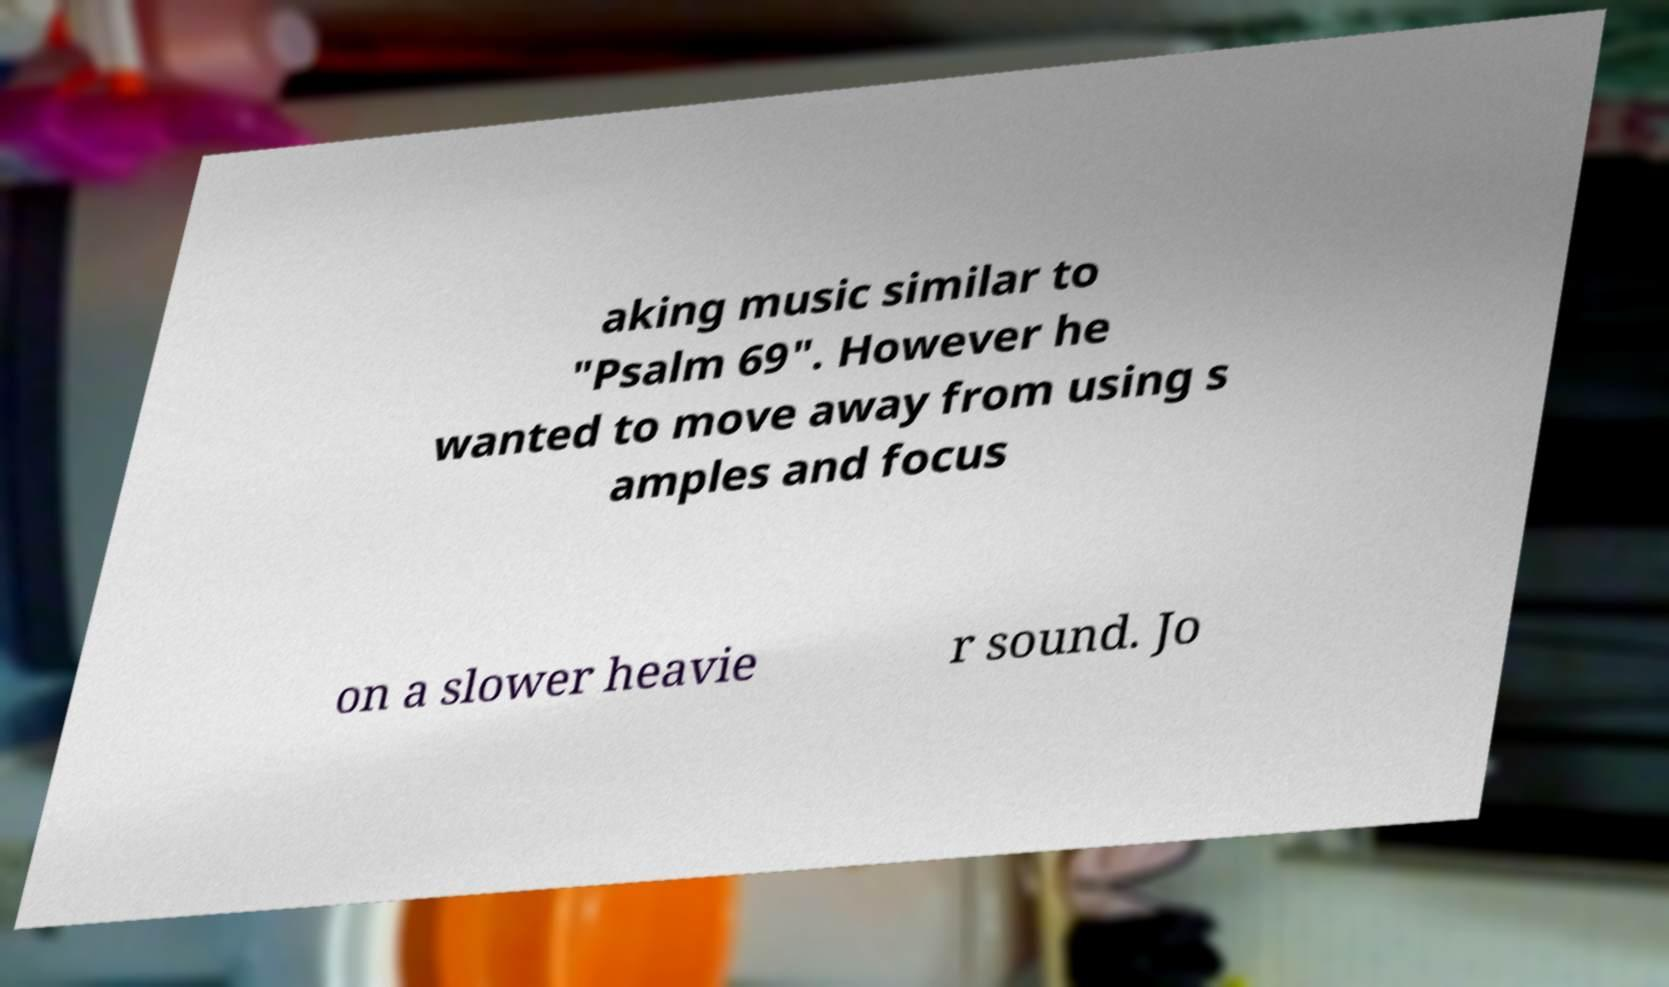Please read and relay the text visible in this image. What does it say? aking music similar to "Psalm 69". However he wanted to move away from using s amples and focus on a slower heavie r sound. Jo 